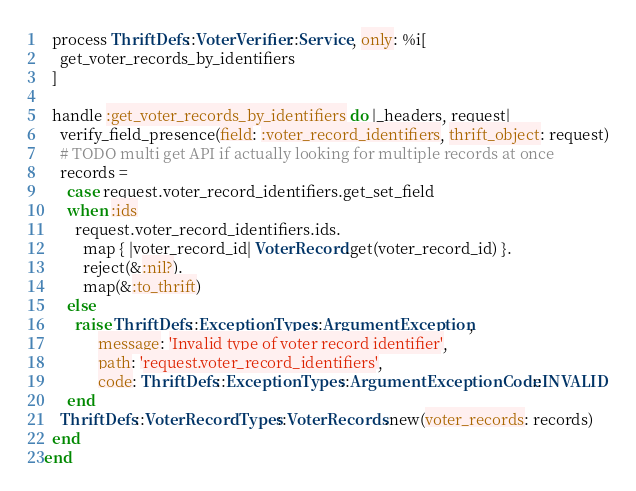Convert code to text. <code><loc_0><loc_0><loc_500><loc_500><_Ruby_>
  process ThriftDefs::VoterVerifier::Service, only: %i[
    get_voter_records_by_identifiers
  ]

  handle :get_voter_records_by_identifiers do |_headers, request|
    verify_field_presence(field: :voter_record_identifiers, thrift_object: request)
    # TODO multi get API if actually looking for multiple records at once
    records =
      case request.voter_record_identifiers.get_set_field
      when :ids
        request.voter_record_identifiers.ids.
          map { |voter_record_id| VoterRecord.get(voter_record_id) }.
          reject(&:nil?).
          map(&:to_thrift)
      else
        raise ThriftDefs::ExceptionTypes::ArgumentException,
              message: 'Invalid type of voter record identifier',
              path: 'request.voter_record_identifiers',
              code: ThriftDefs::ExceptionTypes::ArgumentExceptionCode::INVALID
      end
    ThriftDefs::VoterRecordTypes::VoterRecords.new(voter_records: records)
  end
end
</code> 